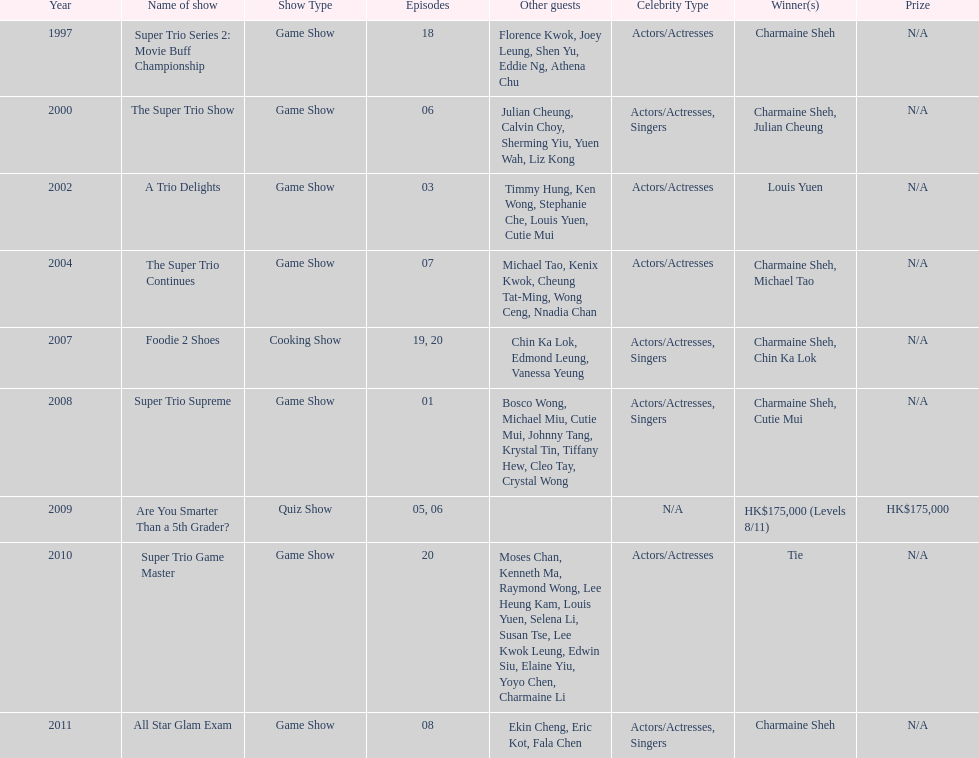How much time has passed since charmaine sheh initially featured on a variety show? 17 years. Would you be able to parse every entry in this table? {'header': ['Year', 'Name of show', 'Show Type', 'Episodes', 'Other guests', 'Celebrity Type', 'Winner(s)', 'Prize'], 'rows': [['1997', 'Super Trio Series 2: Movie Buff Championship', 'Game Show', '18', 'Florence Kwok, Joey Leung, Shen Yu, Eddie Ng, Athena Chu', 'Actors/Actresses', 'Charmaine Sheh', 'N/A'], ['2000', 'The Super Trio Show', 'Game Show', '06', 'Julian Cheung, Calvin Choy, Sherming Yiu, Yuen Wah, Liz Kong', 'Actors/Actresses, Singers', 'Charmaine Sheh, Julian Cheung', 'N/A'], ['2002', 'A Trio Delights', 'Game Show', '03', 'Timmy Hung, Ken Wong, Stephanie Che, Louis Yuen, Cutie Mui', 'Actors/Actresses', 'Louis Yuen', 'N/A'], ['2004', 'The Super Trio Continues', 'Game Show', '07', 'Michael Tao, Kenix Kwok, Cheung Tat-Ming, Wong Ceng, Nnadia Chan', 'Actors/Actresses', 'Charmaine Sheh, Michael Tao', 'N/A'], ['2007', 'Foodie 2 Shoes', 'Cooking Show', '19, 20', 'Chin Ka Lok, Edmond Leung, Vanessa Yeung', 'Actors/Actresses, Singers', 'Charmaine Sheh, Chin Ka Lok', 'N/A'], ['2008', 'Super Trio Supreme', 'Game Show', '01', 'Bosco Wong, Michael Miu, Cutie Mui, Johnny Tang, Krystal Tin, Tiffany Hew, Cleo Tay, Crystal Wong', 'Actors/Actresses, Singers', 'Charmaine Sheh, Cutie Mui', 'N/A'], ['2009', 'Are You Smarter Than a 5th Grader?', 'Quiz Show', '05, 06', '', 'N/A', 'HK$175,000 (Levels 8/11)', 'HK$175,000'], ['2010', 'Super Trio Game Master', 'Game Show', '20', 'Moses Chan, Kenneth Ma, Raymond Wong, Lee Heung Kam, Louis Yuen, Selena Li, Susan Tse, Lee Kwok Leung, Edwin Siu, Elaine Yiu, Yoyo Chen, Charmaine Li', 'Actors/Actresses', 'Tie', 'N/A'], ['2011', 'All Star Glam Exam', 'Game Show', '08', 'Ekin Cheng, Eric Kot, Fala Chen', 'Actors/Actresses, Singers', 'Charmaine Sheh', 'N/A']]} 